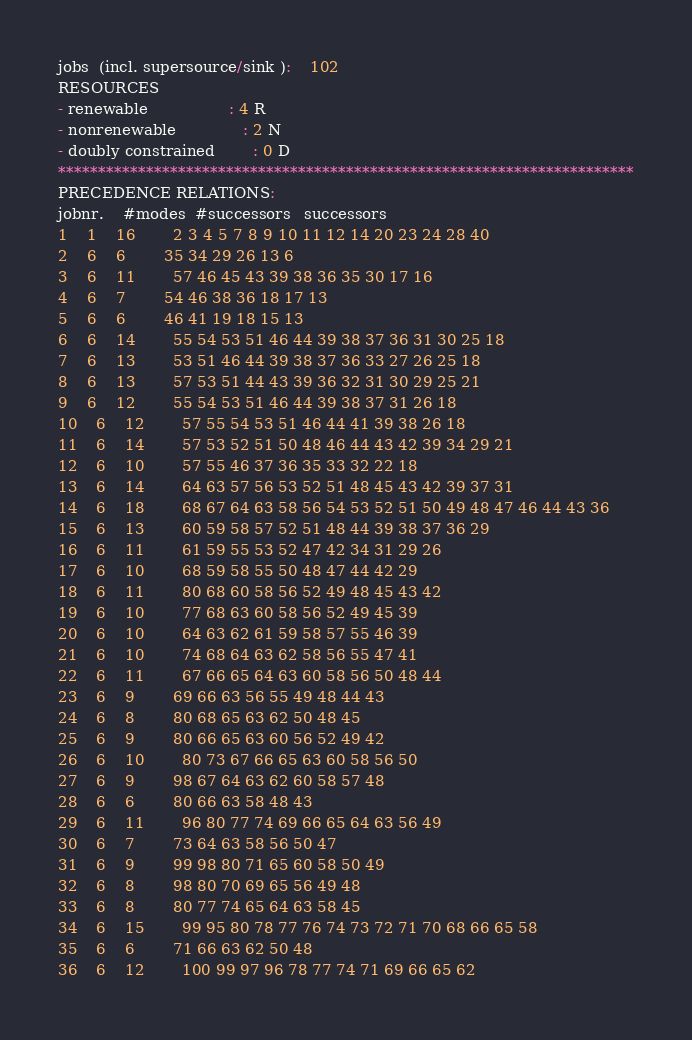<code> <loc_0><loc_0><loc_500><loc_500><_ObjectiveC_>jobs  (incl. supersource/sink ):	102
RESOURCES
- renewable                 : 4 R
- nonrenewable              : 2 N
- doubly constrained        : 0 D
************************************************************************
PRECEDENCE RELATIONS:
jobnr.    #modes  #successors   successors
1	1	16		2 3 4 5 7 8 9 10 11 12 14 20 23 24 28 40 
2	6	6		35 34 29 26 13 6 
3	6	11		57 46 45 43 39 38 36 35 30 17 16 
4	6	7		54 46 38 36 18 17 13 
5	6	6		46 41 19 18 15 13 
6	6	14		55 54 53 51 46 44 39 38 37 36 31 30 25 18 
7	6	13		53 51 46 44 39 38 37 36 33 27 26 25 18 
8	6	13		57 53 51 44 43 39 36 32 31 30 29 25 21 
9	6	12		55 54 53 51 46 44 39 38 37 31 26 18 
10	6	12		57 55 54 53 51 46 44 41 39 38 26 18 
11	6	14		57 53 52 51 50 48 46 44 43 42 39 34 29 21 
12	6	10		57 55 46 37 36 35 33 32 22 18 
13	6	14		64 63 57 56 53 52 51 48 45 43 42 39 37 31 
14	6	18		68 67 64 63 58 56 54 53 52 51 50 49 48 47 46 44 43 36 
15	6	13		60 59 58 57 52 51 48 44 39 38 37 36 29 
16	6	11		61 59 55 53 52 47 42 34 31 29 26 
17	6	10		68 59 58 55 50 48 47 44 42 29 
18	6	11		80 68 60 58 56 52 49 48 45 43 42 
19	6	10		77 68 63 60 58 56 52 49 45 39 
20	6	10		64 63 62 61 59 58 57 55 46 39 
21	6	10		74 68 64 63 62 58 56 55 47 41 
22	6	11		67 66 65 64 63 60 58 56 50 48 44 
23	6	9		69 66 63 56 55 49 48 44 43 
24	6	8		80 68 65 63 62 50 48 45 
25	6	9		80 66 65 63 60 56 52 49 42 
26	6	10		80 73 67 66 65 63 60 58 56 50 
27	6	9		98 67 64 63 62 60 58 57 48 
28	6	6		80 66 63 58 48 43 
29	6	11		96 80 77 74 69 66 65 64 63 56 49 
30	6	7		73 64 63 58 56 50 47 
31	6	9		99 98 80 71 65 60 58 50 49 
32	6	8		98 80 70 69 65 56 49 48 
33	6	8		80 77 74 65 64 63 58 45 
34	6	15		99 95 80 78 77 76 74 73 72 71 70 68 66 65 58 
35	6	6		71 66 63 62 50 48 
36	6	12		100 99 97 96 78 77 74 71 69 66 65 62 </code> 